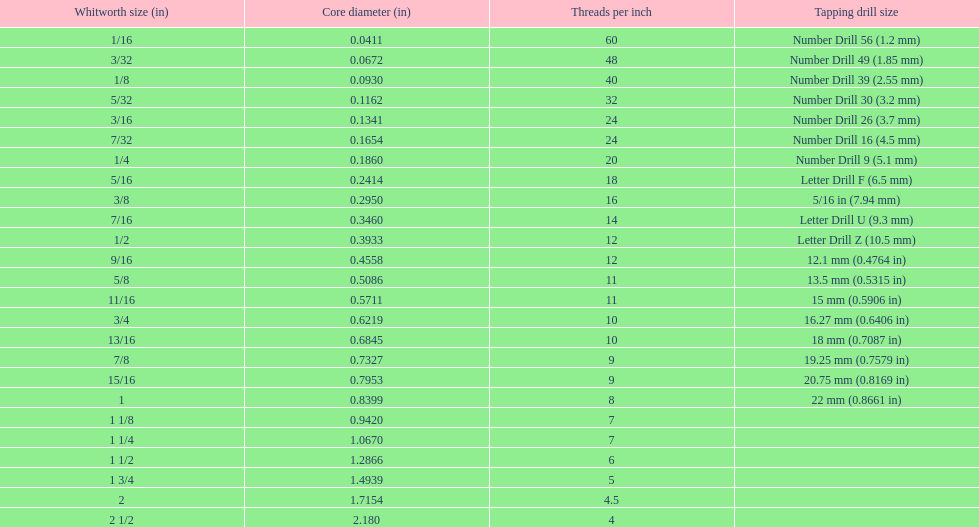What is the core diameter of the first 1/8 whitworth size (in)? 0.0930. 